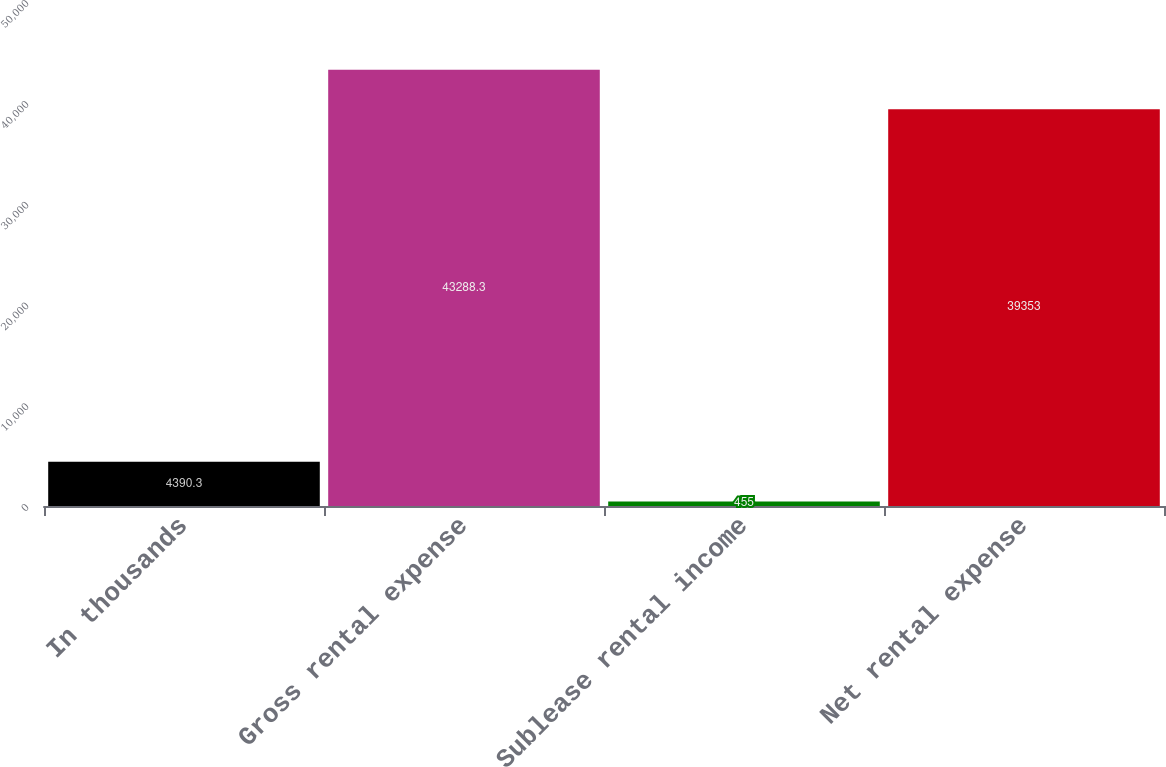<chart> <loc_0><loc_0><loc_500><loc_500><bar_chart><fcel>In thousands<fcel>Gross rental expense<fcel>Sublease rental income<fcel>Net rental expense<nl><fcel>4390.3<fcel>43288.3<fcel>455<fcel>39353<nl></chart> 